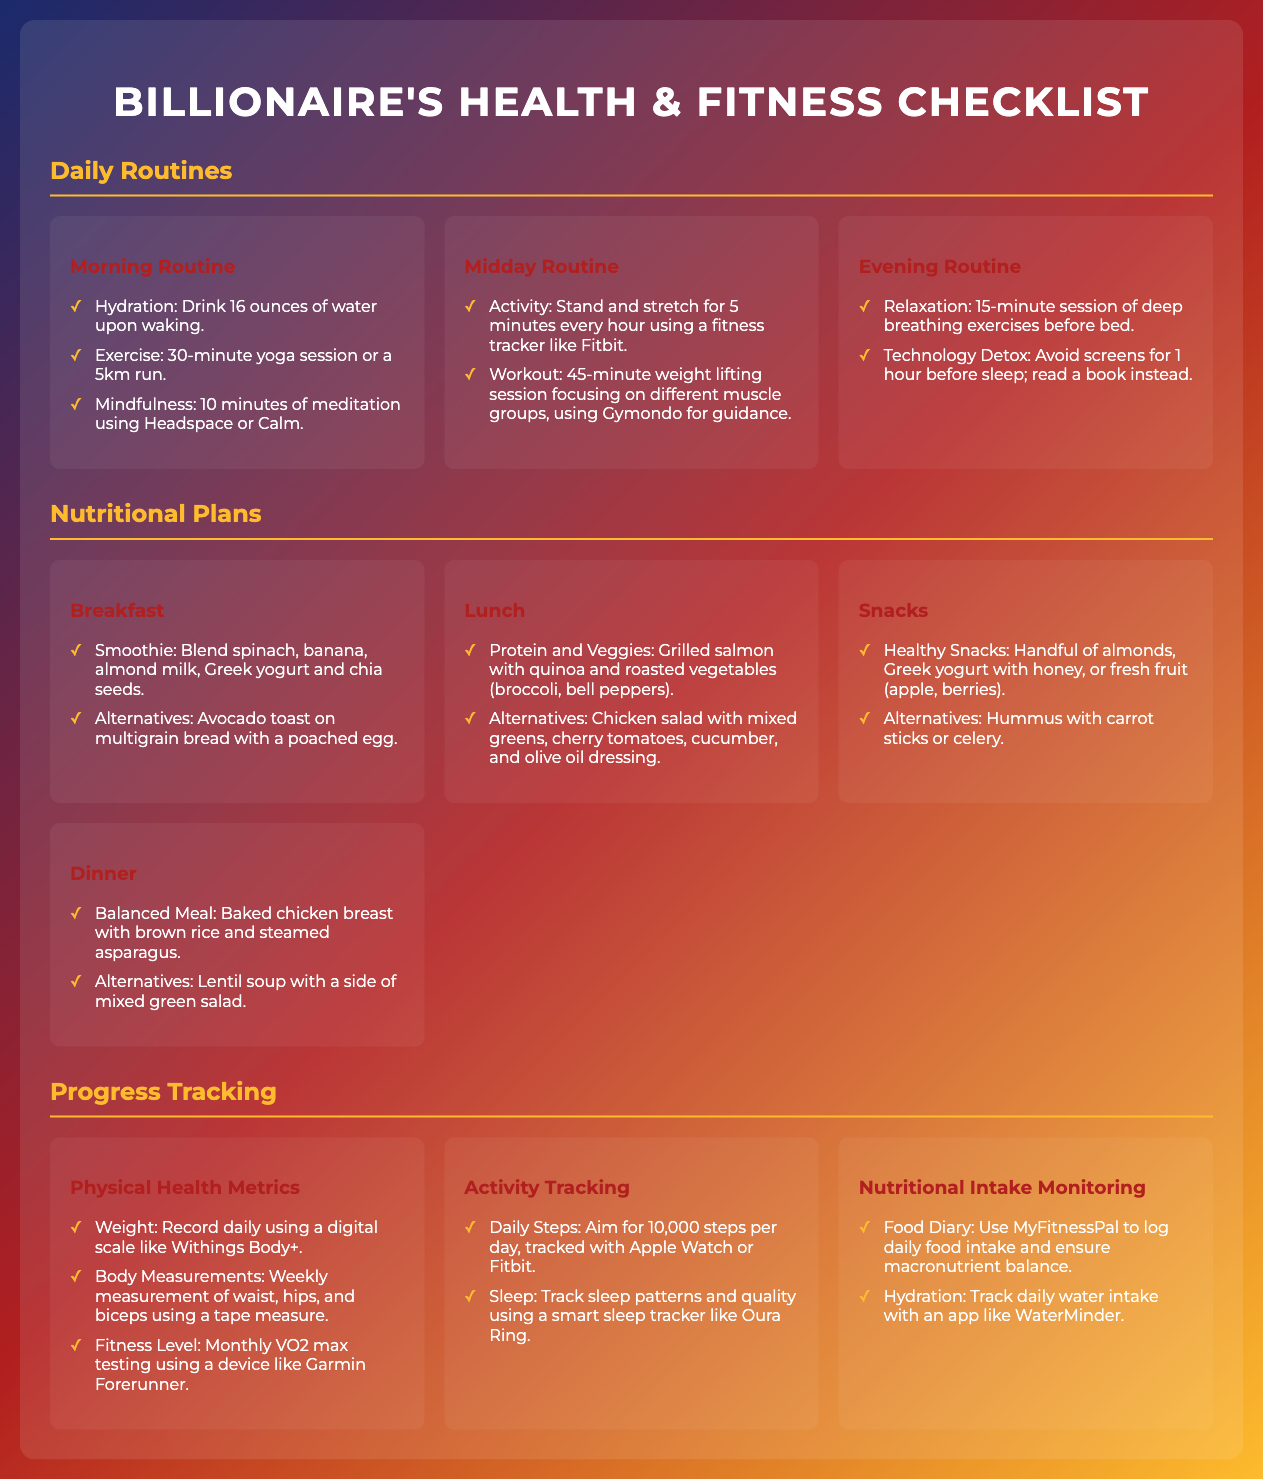What is the hydration goal upon waking? The document states to drink 16 ounces of water upon waking as part of the morning routine.
Answer: 16 ounces How long is the yoga session recommended in the morning routine? The checklist mentions a 30-minute yoga session as part of the morning routine.
Answer: 30 minutes What is included in the lunch nutritional plan? The lunch section specifies grilled salmon with quinoa and roasted vegetables.
Answer: Grilled salmon with quinoa and roasted vegetables How many times per week should body measurements be taken? The document indicates body measurements should be taken weekly.
Answer: Weekly What is the aimed daily step count? The checklist specifies an aim of 10,000 steps per day for activity tracking.
Answer: 10,000 steps How long should technology be avoided before sleep? The evening routine advises avoiding screens for 1 hour before sleep.
Answer: 1 hour What is advised for snacks? The document suggests healthy snacks such as a handful of almonds or Greek yogurt with honey.
Answer: Handful of almonds Which app is recommended for tracking food intake? The checklist mentions using MyFitnessPal to log daily food intake.
Answer: MyFitnessPal What type of exercise is suggested for the midday routine? The midday routine includes a 45-minute weight lifting session focusing on different muscle groups.
Answer: 45-minute weight lifting session 